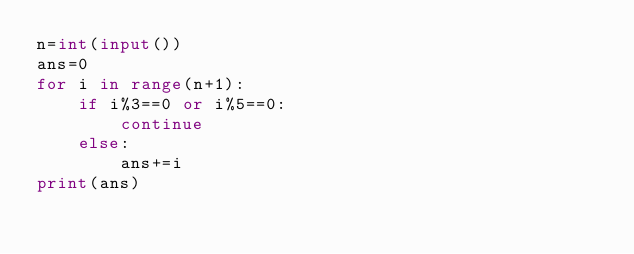<code> <loc_0><loc_0><loc_500><loc_500><_Python_>n=int(input())
ans=0
for i in range(n+1):
    if i%3==0 or i%5==0:
        continue
    else:
        ans+=i
print(ans)</code> 